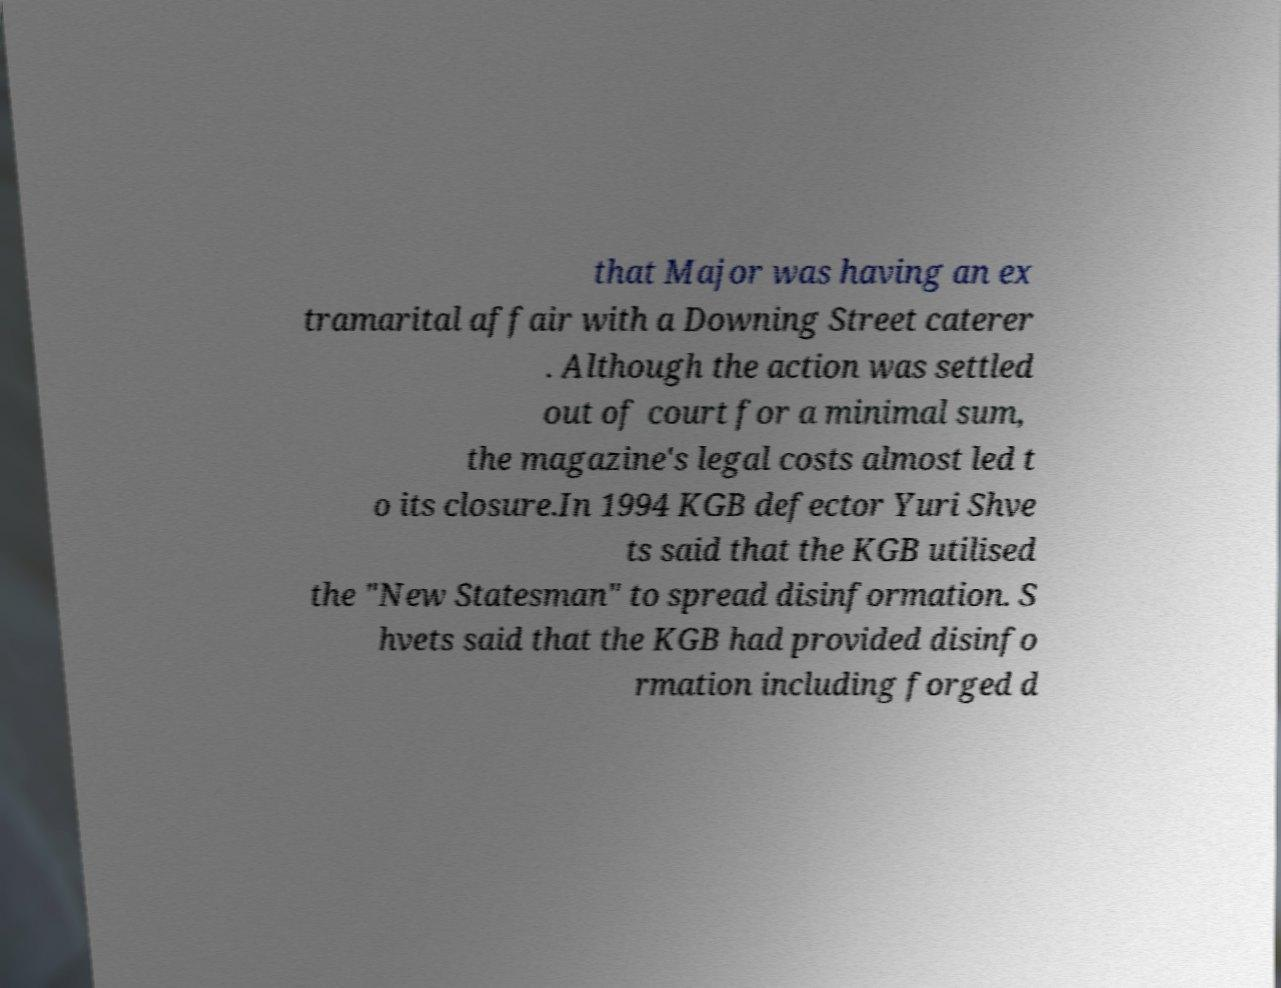For documentation purposes, I need the text within this image transcribed. Could you provide that? that Major was having an ex tramarital affair with a Downing Street caterer . Although the action was settled out of court for a minimal sum, the magazine's legal costs almost led t o its closure.In 1994 KGB defector Yuri Shve ts said that the KGB utilised the "New Statesman" to spread disinformation. S hvets said that the KGB had provided disinfo rmation including forged d 